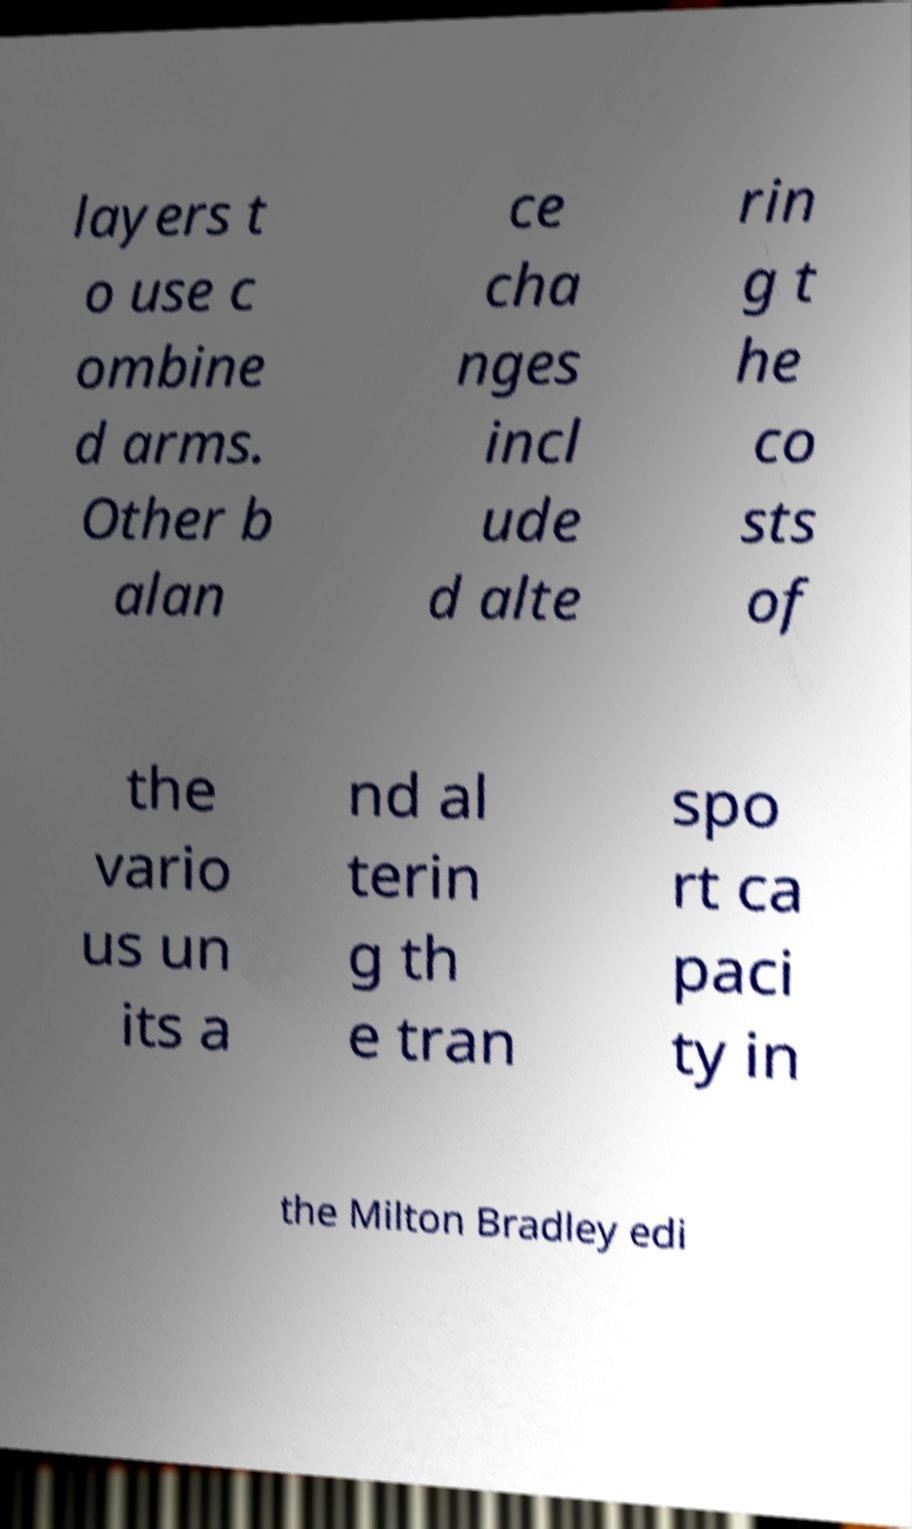Can you read and provide the text displayed in the image?This photo seems to have some interesting text. Can you extract and type it out for me? layers t o use c ombine d arms. Other b alan ce cha nges incl ude d alte rin g t he co sts of the vario us un its a nd al terin g th e tran spo rt ca paci ty in the Milton Bradley edi 